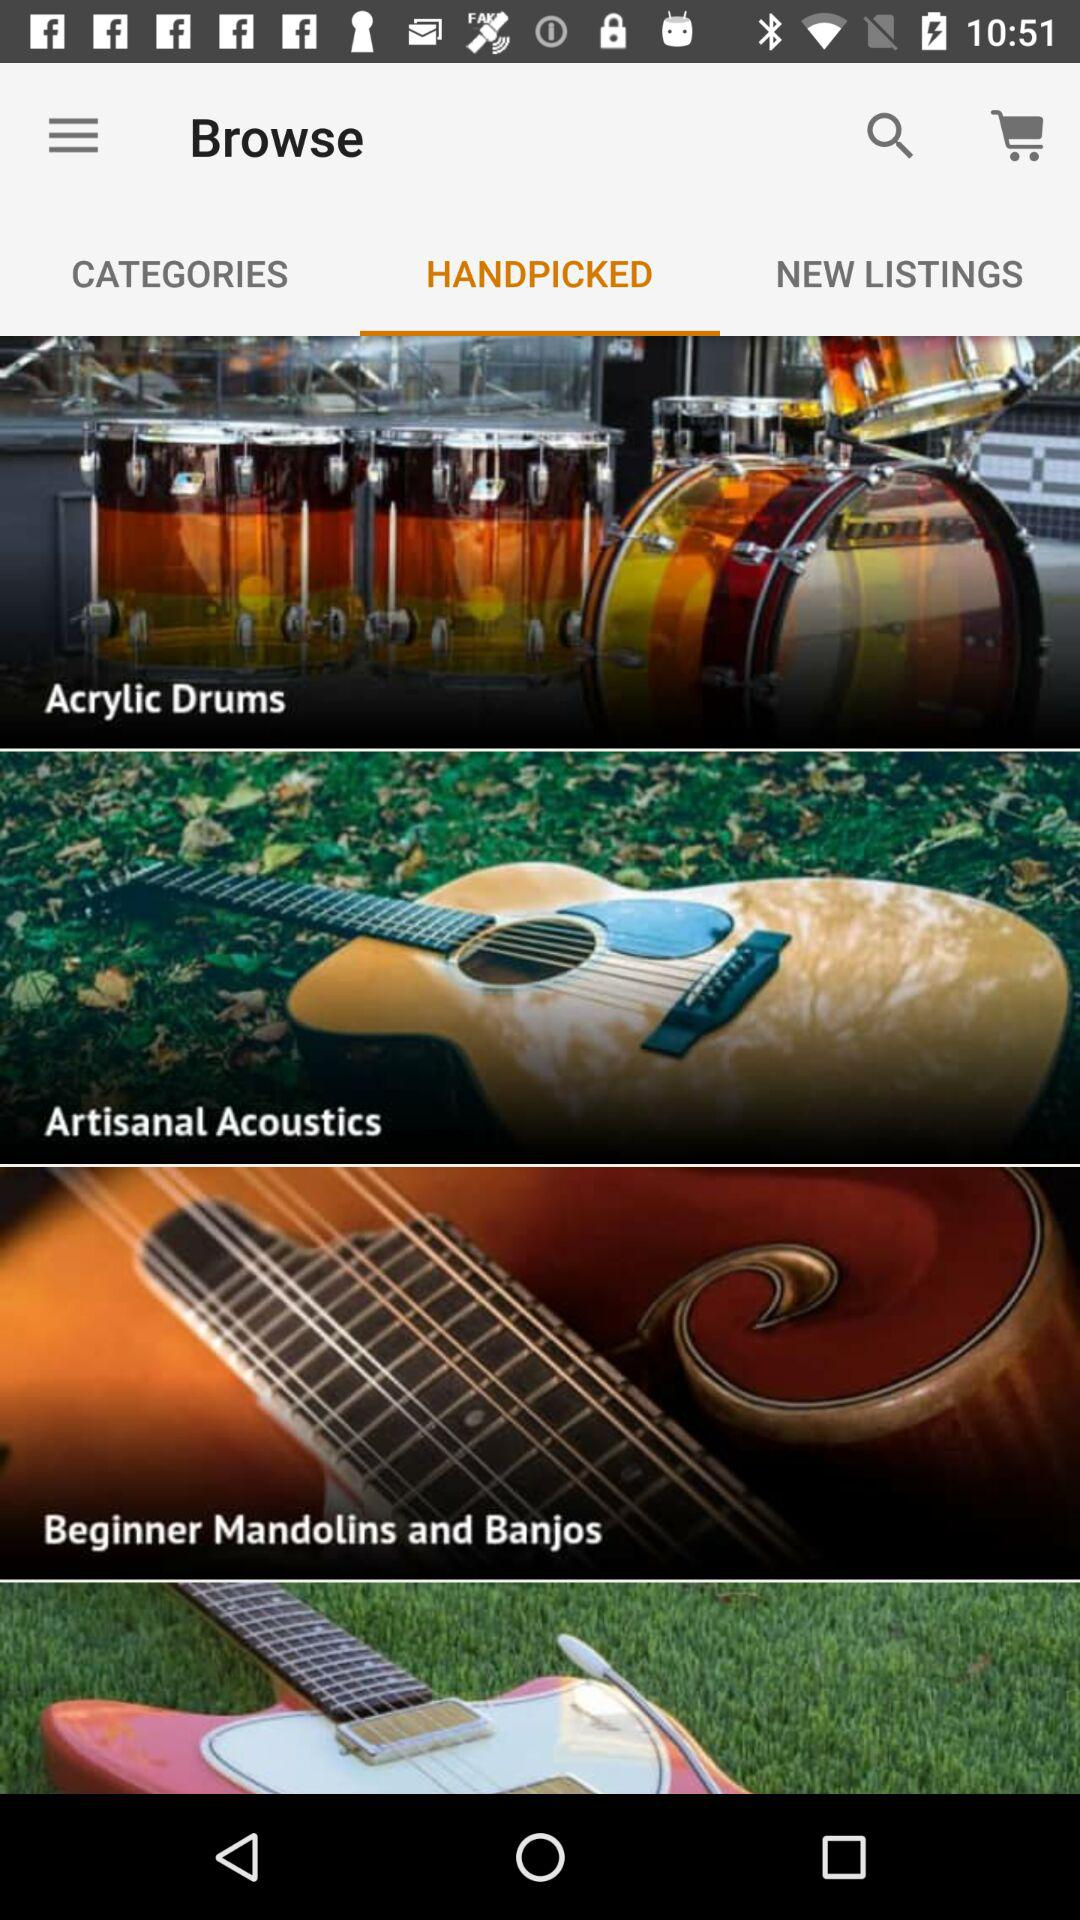What musical instruments are there? There are acrylic drums, artisanal acoustics and beginner mandolins and banjos. 